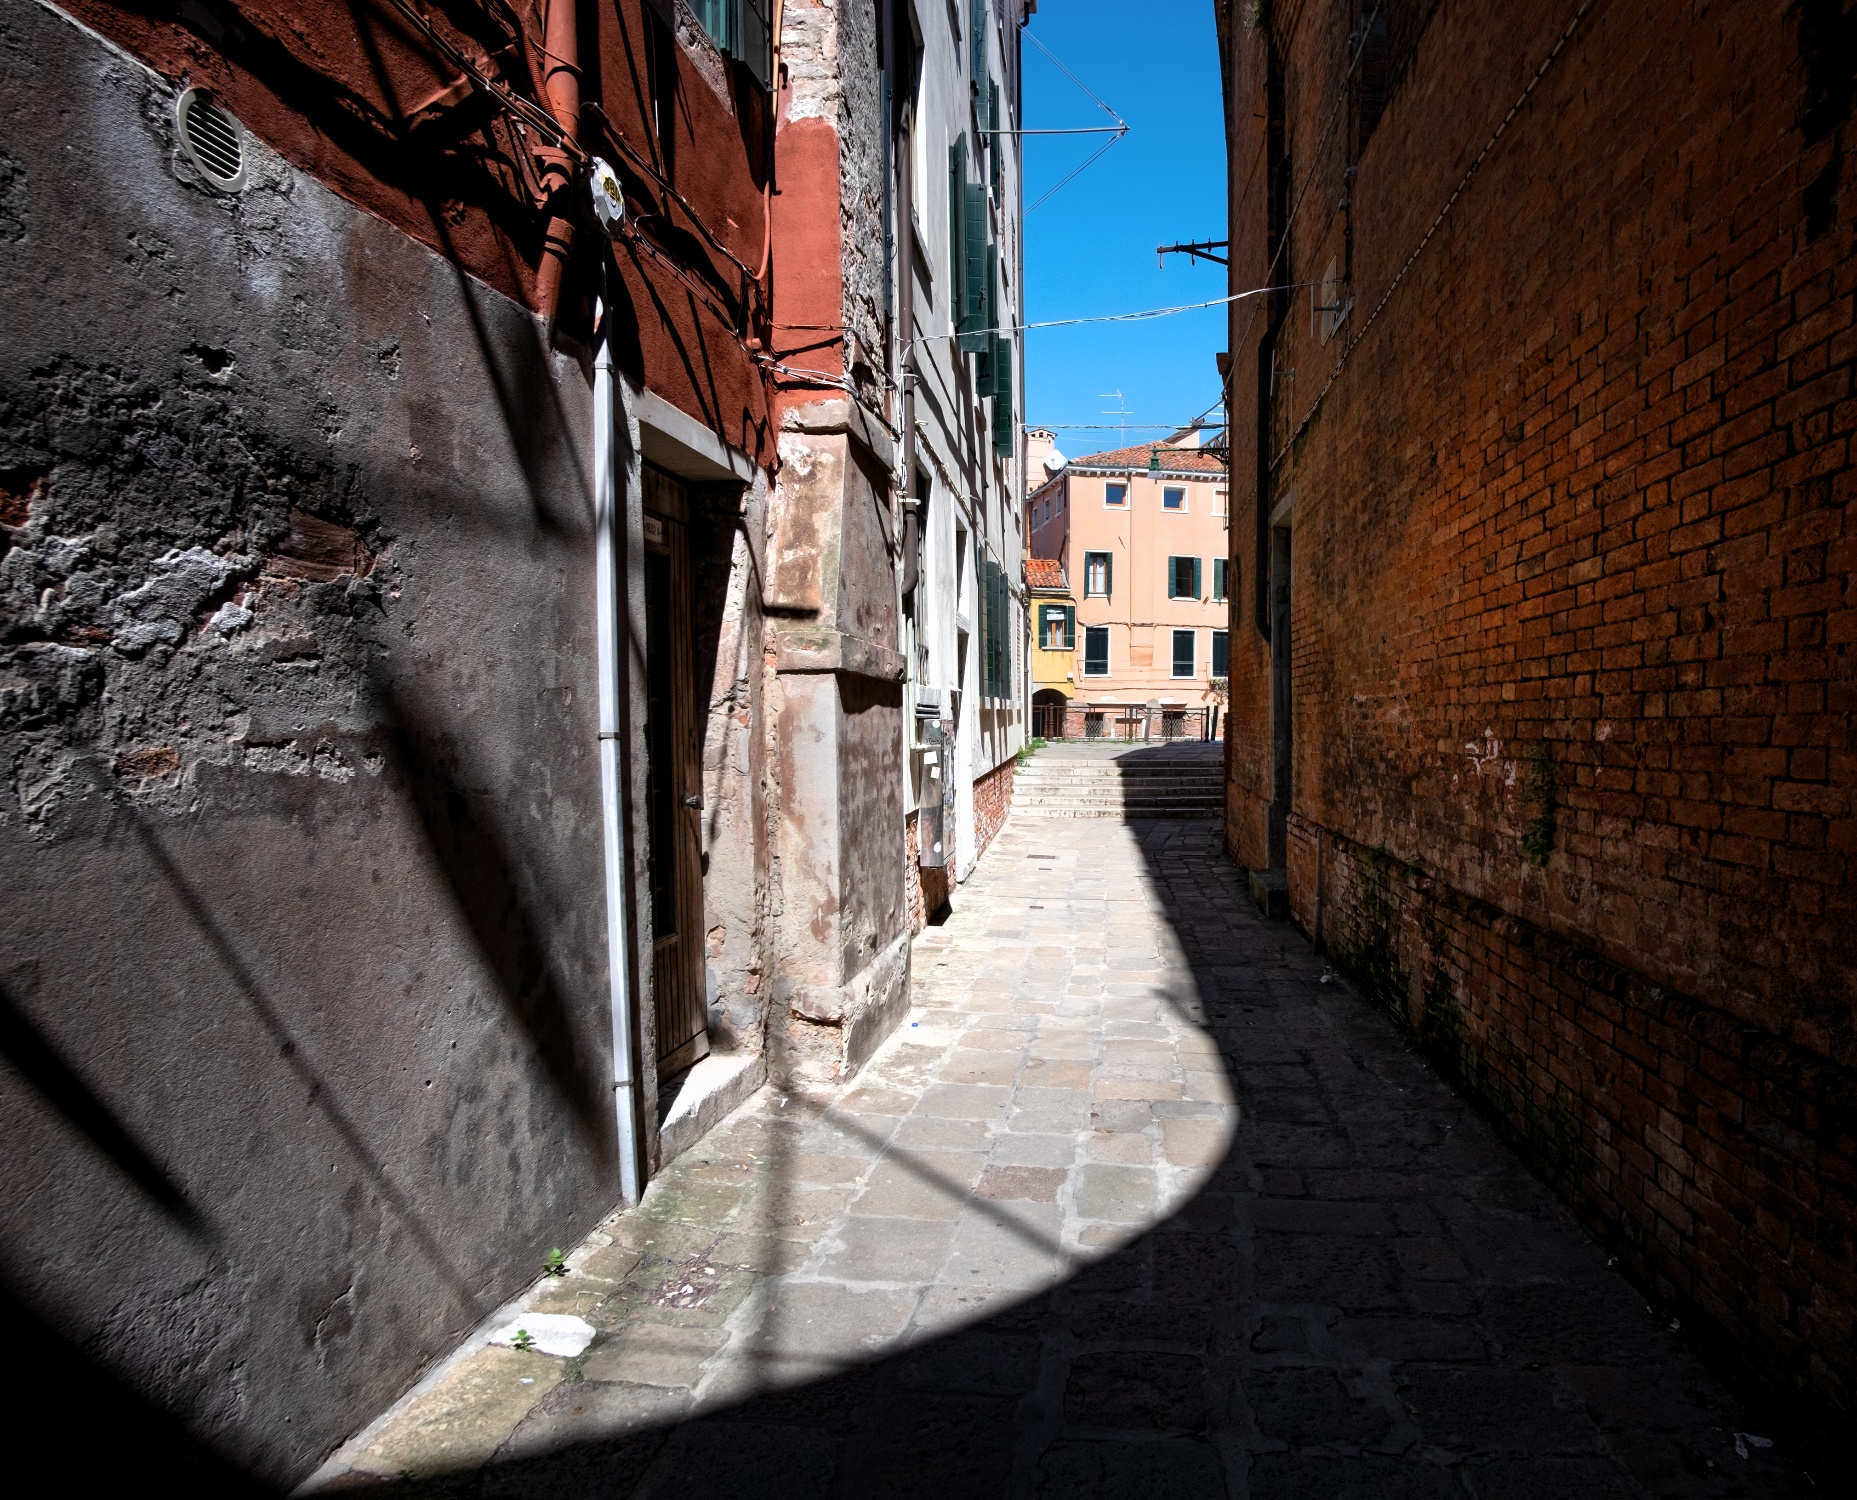Can you create a whimsical poem inspired by this alley? In a Venice alley, narrow and bright,
Where shadows dance in morning light,
Time-carved bricks of red and gold,
Whisper secrets, stories untold.

Cobblestone path, sunlit and fair,
Guards the whispers floating in the air,
Clotheslines swinging with tales past,
Binding moments meant to last.

Magic hums in every crack,
Walls tuned to history’s track,
A symphony of silence sings,
Of life's essence, simple things.

Morning kisses stones and brick,
Creating scenes that sweetly stick,
In memory’s gallery, framed with care,
This Venice alley, beyond compare. 